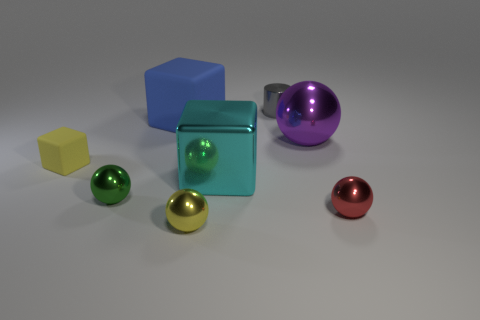What is the shape of the shiny object that is behind the large thing that is left of the yellow object in front of the small red object?
Ensure brevity in your answer.  Cylinder. The large block right of the tiny yellow metallic thing is what color?
Your answer should be compact. Cyan. How many things are either large cubes that are behind the purple shiny thing or tiny yellow objects behind the large cyan block?
Your answer should be compact. 2. What number of rubber objects have the same shape as the cyan metallic thing?
Offer a very short reply. 2. There is a matte cube that is the same size as the cyan metal thing; what color is it?
Keep it short and to the point. Blue. There is a large cube in front of the metallic ball that is behind the tiny yellow object that is to the left of the yellow sphere; what color is it?
Make the answer very short. Cyan. Is the size of the red object the same as the matte object that is on the right side of the tiny green metallic sphere?
Your response must be concise. No. How many objects are large yellow blocks or tiny metal cylinders?
Your answer should be very brief. 1. Are there any yellow balls that have the same material as the gray object?
Provide a short and direct response. Yes. What is the size of the metal object that is the same color as the small block?
Offer a very short reply. Small. 